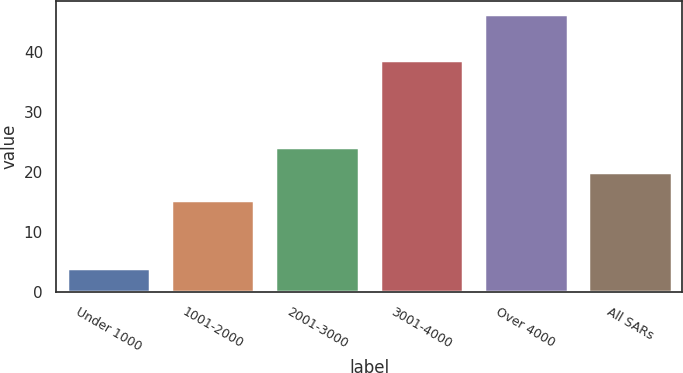Convert chart to OTSL. <chart><loc_0><loc_0><loc_500><loc_500><bar_chart><fcel>Under 1000<fcel>1001-2000<fcel>2001-3000<fcel>3001-4000<fcel>Over 4000<fcel>All SARs<nl><fcel>4.08<fcel>15.36<fcel>24.2<fcel>38.68<fcel>46.32<fcel>19.98<nl></chart> 